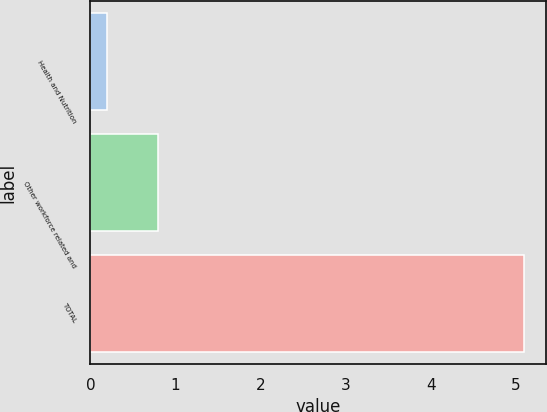<chart> <loc_0><loc_0><loc_500><loc_500><bar_chart><fcel>Health and Nutrition<fcel>Other workforce related and<fcel>TOTAL<nl><fcel>0.2<fcel>0.8<fcel>5.1<nl></chart> 